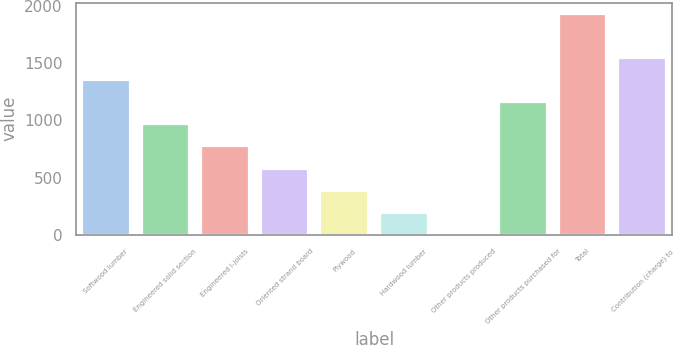Convert chart to OTSL. <chart><loc_0><loc_0><loc_500><loc_500><bar_chart><fcel>Softwood lumber<fcel>Engineered solid section<fcel>Engineered I-joists<fcel>Oriented strand board<fcel>Plywood<fcel>Hardwood lumber<fcel>Other products produced<fcel>Other products purchased for<fcel>Total<fcel>Contribution (charge) to<nl><fcel>1352<fcel>966<fcel>773<fcel>580<fcel>387<fcel>194<fcel>1<fcel>1159<fcel>1931<fcel>1545<nl></chart> 